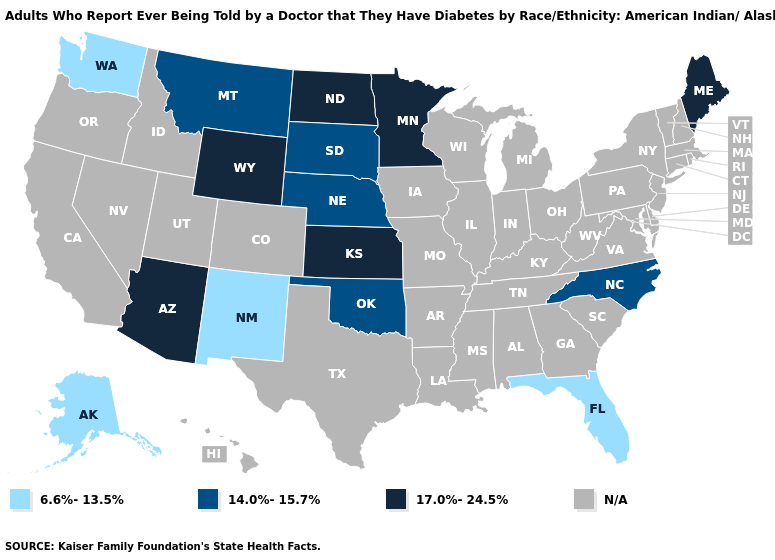What is the value of Washington?
Quick response, please. 6.6%-13.5%. What is the highest value in the USA?
Keep it brief. 17.0%-24.5%. Name the states that have a value in the range 14.0%-15.7%?
Be succinct. Montana, Nebraska, North Carolina, Oklahoma, South Dakota. What is the value of Oregon?
Short answer required. N/A. Name the states that have a value in the range 6.6%-13.5%?
Short answer required. Alaska, Florida, New Mexico, Washington. Does Nebraska have the highest value in the MidWest?
Quick response, please. No. Among the states that border South Dakota , which have the highest value?
Answer briefly. Minnesota, North Dakota, Wyoming. Name the states that have a value in the range 6.6%-13.5%?
Keep it brief. Alaska, Florida, New Mexico, Washington. Name the states that have a value in the range N/A?
Be succinct. Alabama, Arkansas, California, Colorado, Connecticut, Delaware, Georgia, Hawaii, Idaho, Illinois, Indiana, Iowa, Kentucky, Louisiana, Maryland, Massachusetts, Michigan, Mississippi, Missouri, Nevada, New Hampshire, New Jersey, New York, Ohio, Oregon, Pennsylvania, Rhode Island, South Carolina, Tennessee, Texas, Utah, Vermont, Virginia, West Virginia, Wisconsin. Which states have the lowest value in the West?
Give a very brief answer. Alaska, New Mexico, Washington. What is the value of New Hampshire?
Quick response, please. N/A. Name the states that have a value in the range N/A?
Answer briefly. Alabama, Arkansas, California, Colorado, Connecticut, Delaware, Georgia, Hawaii, Idaho, Illinois, Indiana, Iowa, Kentucky, Louisiana, Maryland, Massachusetts, Michigan, Mississippi, Missouri, Nevada, New Hampshire, New Jersey, New York, Ohio, Oregon, Pennsylvania, Rhode Island, South Carolina, Tennessee, Texas, Utah, Vermont, Virginia, West Virginia, Wisconsin. What is the value of Idaho?
Short answer required. N/A. What is the value of South Dakota?
Quick response, please. 14.0%-15.7%. 